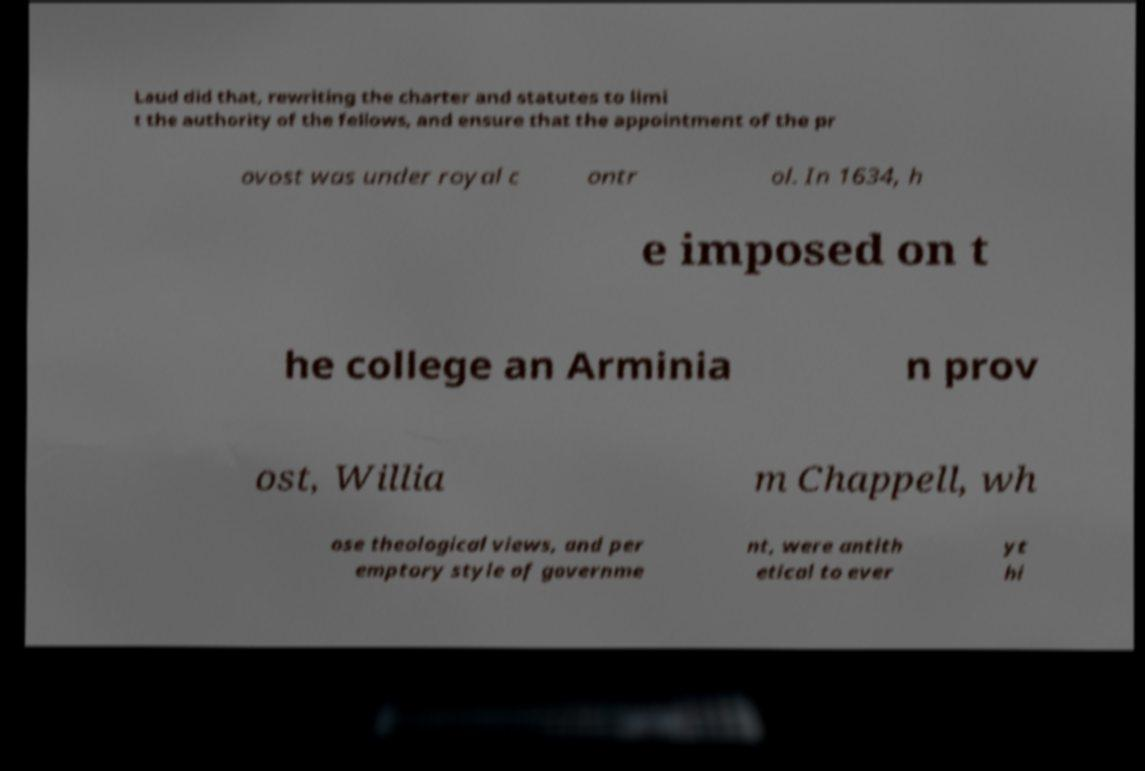Can you accurately transcribe the text from the provided image for me? Laud did that, rewriting the charter and statutes to limi t the authority of the fellows, and ensure that the appointment of the pr ovost was under royal c ontr ol. In 1634, h e imposed on t he college an Arminia n prov ost, Willia m Chappell, wh ose theological views, and per emptory style of governme nt, were antith etical to ever yt hi 